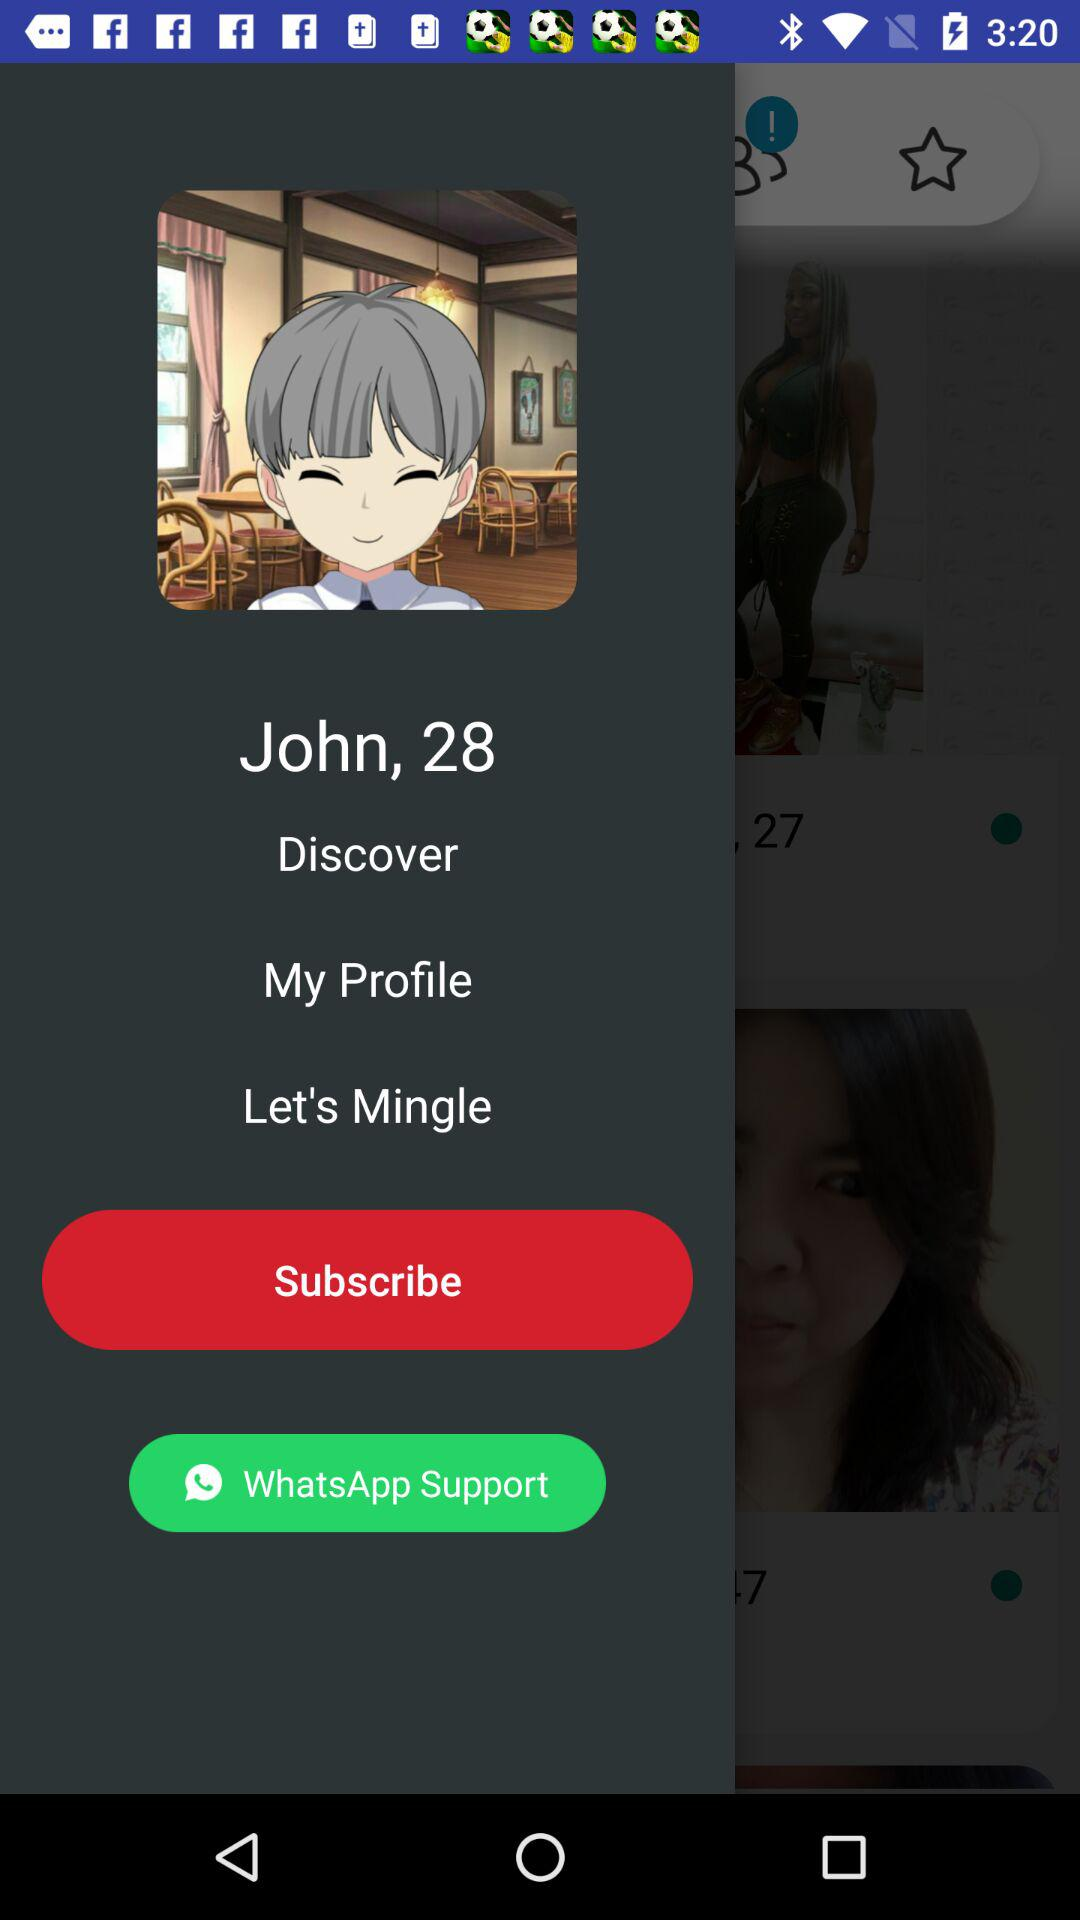What is the user name? The user name is John. 